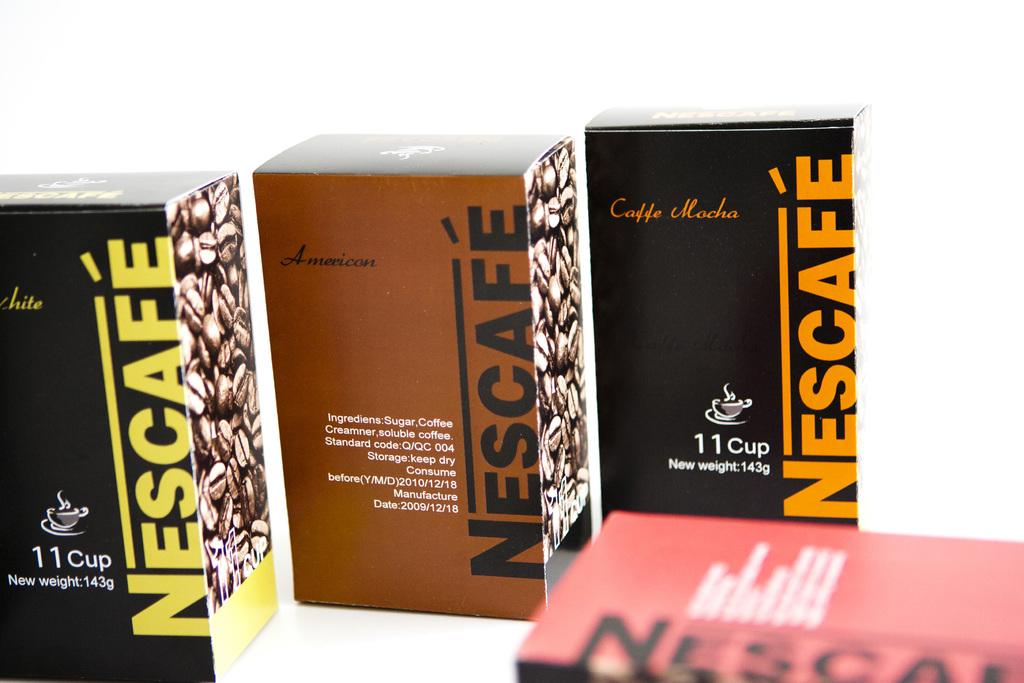<image>
Render a clear and concise summary of the photo. Several different flavors of Nescafe coffee are shown. 